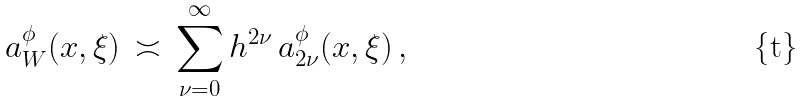Convert formula to latex. <formula><loc_0><loc_0><loc_500><loc_500>a ^ { \phi } _ { W } ( x , \xi ) \, \asymp \, \sum _ { \nu = 0 } ^ { \infty } h ^ { 2 \nu } \, a _ { 2 \nu } ^ { \phi } ( x , \xi ) \, ,</formula> 